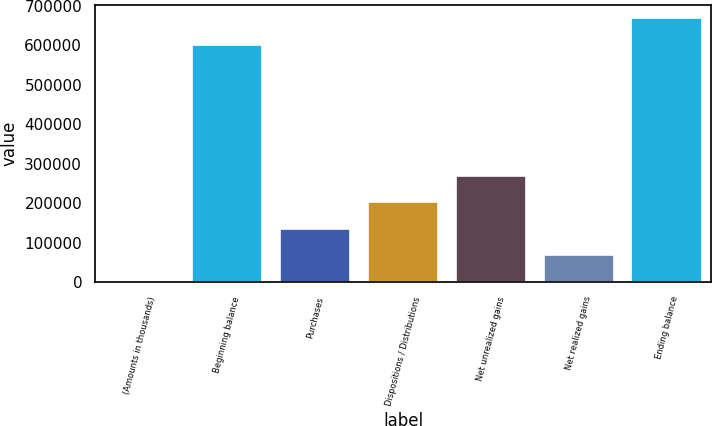Convert chart to OTSL. <chart><loc_0><loc_0><loc_500><loc_500><bar_chart><fcel>(Amounts in thousands)<fcel>Beginning balance<fcel>Purchases<fcel>Dispositions / Distributions<fcel>Net unrealized gains<fcel>Net realized gains<fcel>Ending balance<nl><fcel>2013<fcel>600786<fcel>135152<fcel>201722<fcel>268292<fcel>68582.7<fcel>667710<nl></chart> 